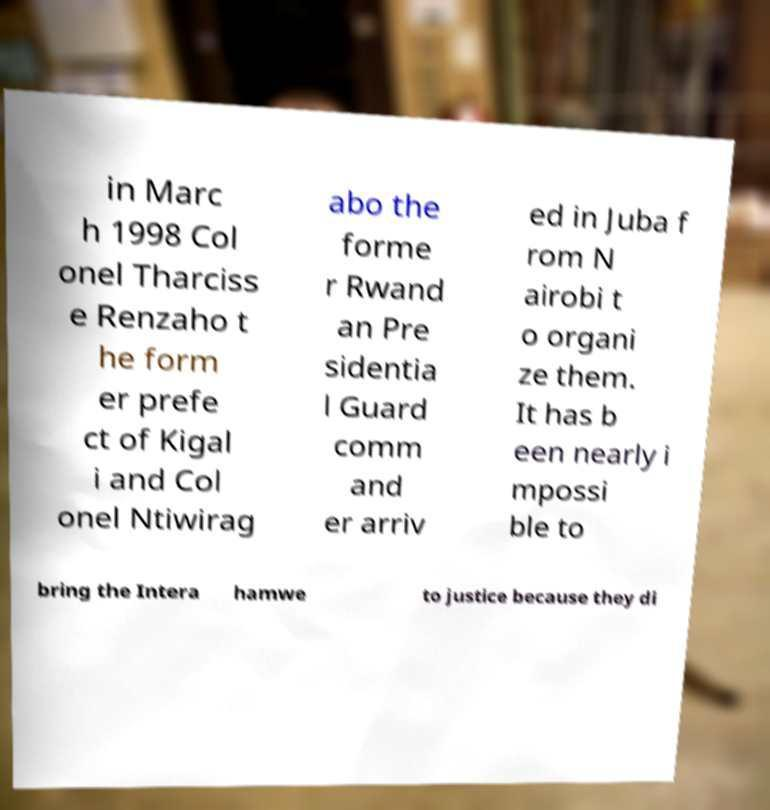Please identify and transcribe the text found in this image. in Marc h 1998 Col onel Tharciss e Renzaho t he form er prefe ct of Kigal i and Col onel Ntiwirag abo the forme r Rwand an Pre sidentia l Guard comm and er arriv ed in Juba f rom N airobi t o organi ze them. It has b een nearly i mpossi ble to bring the Intera hamwe to justice because they di 